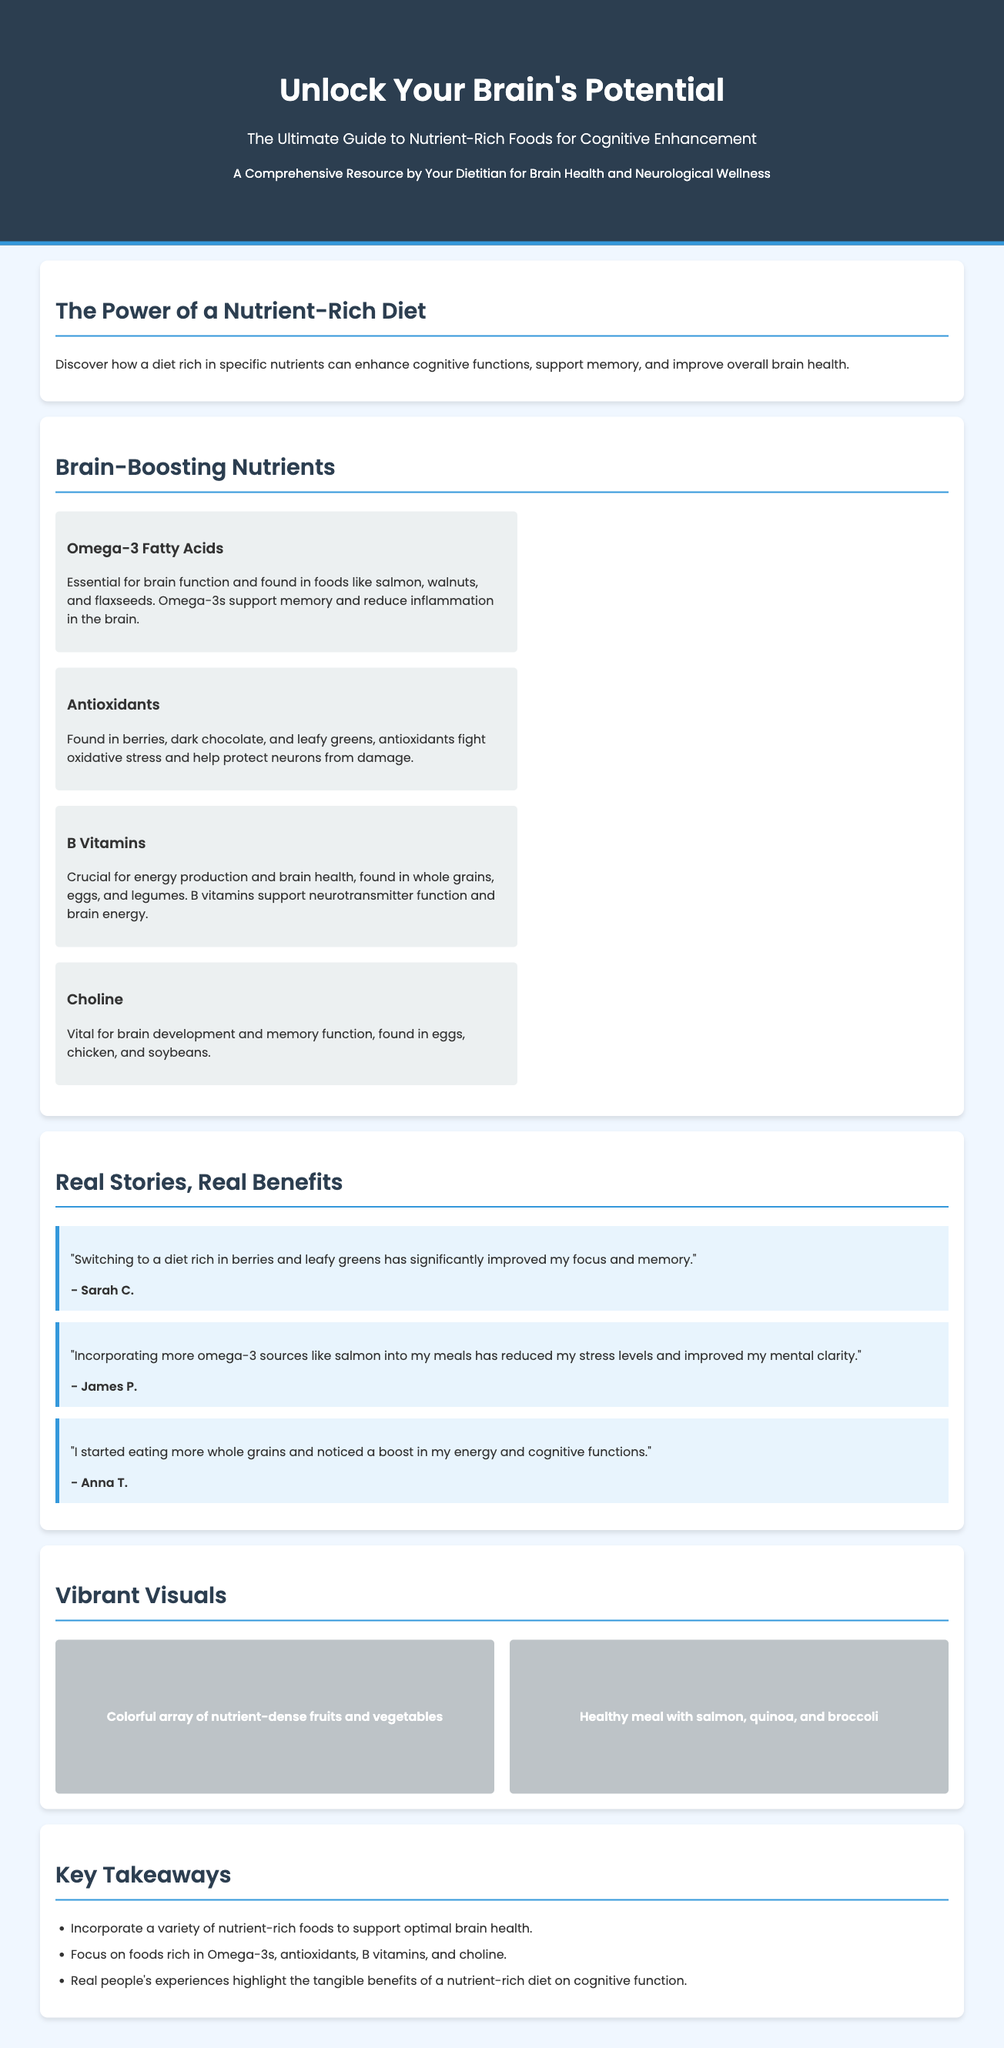What is the title of the guide? The title of the guide is prominently displayed at the top of the document under the heading "Unlock Your Brain's Potential".
Answer: Unlock Your Brain's Potential How many brain-boosting nutrients are highlighted? The document lists four specific nutrients categorized as brain-boosting nutrients.
Answer: Four What food source is rich in Omega-3 fatty acids? Omega-3 fatty acids are specifically mentioned to be found in foods like salmon, walnuts, and flaxseeds.
Answer: Salmon Who is quoted in the testimonial about eating more whole grains? Anna T. is the person cited in the testimonial related to whole grains.
Answer: Anna T What color are the visuals depicting nutrient-dense foods? The visuals described include a "Colorful array of nutrient-dense fruits and vegetables".
Answer: Colorful What do the testimonials illustrate? The testimonials showcase individual experiences related to the cognitive benefits achieved from dietary changes.
Answer: Real benefits What nutrient is vital for brain development mentioned in the guide? Choline is highlighted as a vital nutrient for brain development and memory function.
Answer: Choline Which protective compounds are found in berries and dark chocolate? Antioxidants are noted as the protective compounds present in berries and dark chocolate.
Answer: Antioxidants 